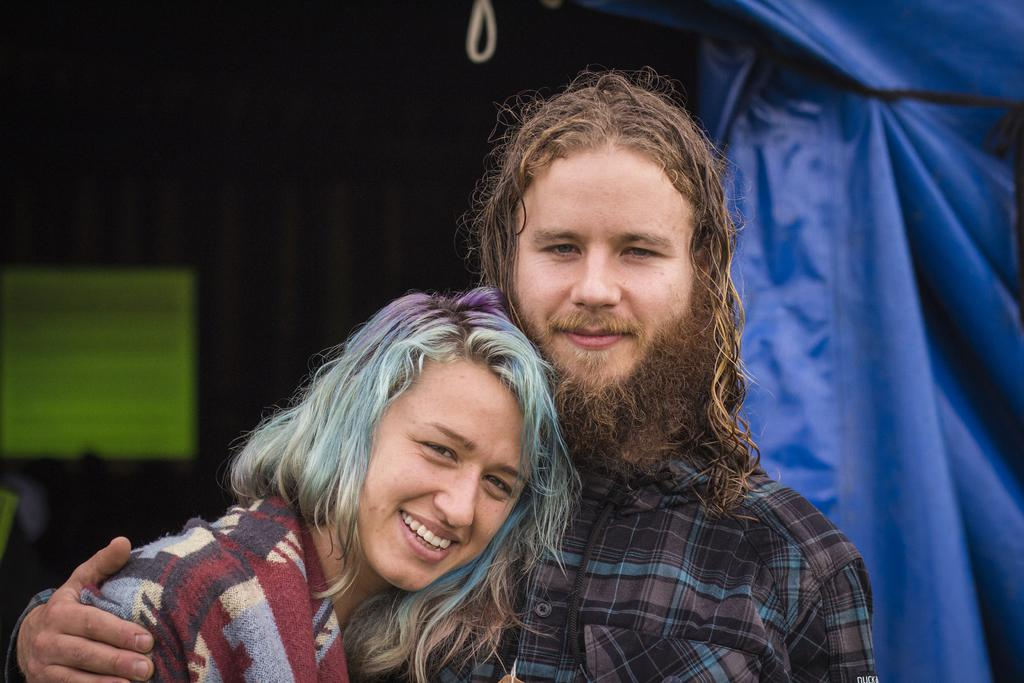Who are the people in the image? There is a man and a lady in the image. What color is the cover visible in the image? The cover in the image is blue. How would you describe the background of the image? The background of the image is blurred. What type of flowers can be seen growing on the man's head in the image? There are no flowers visible on the man's head in the image. 